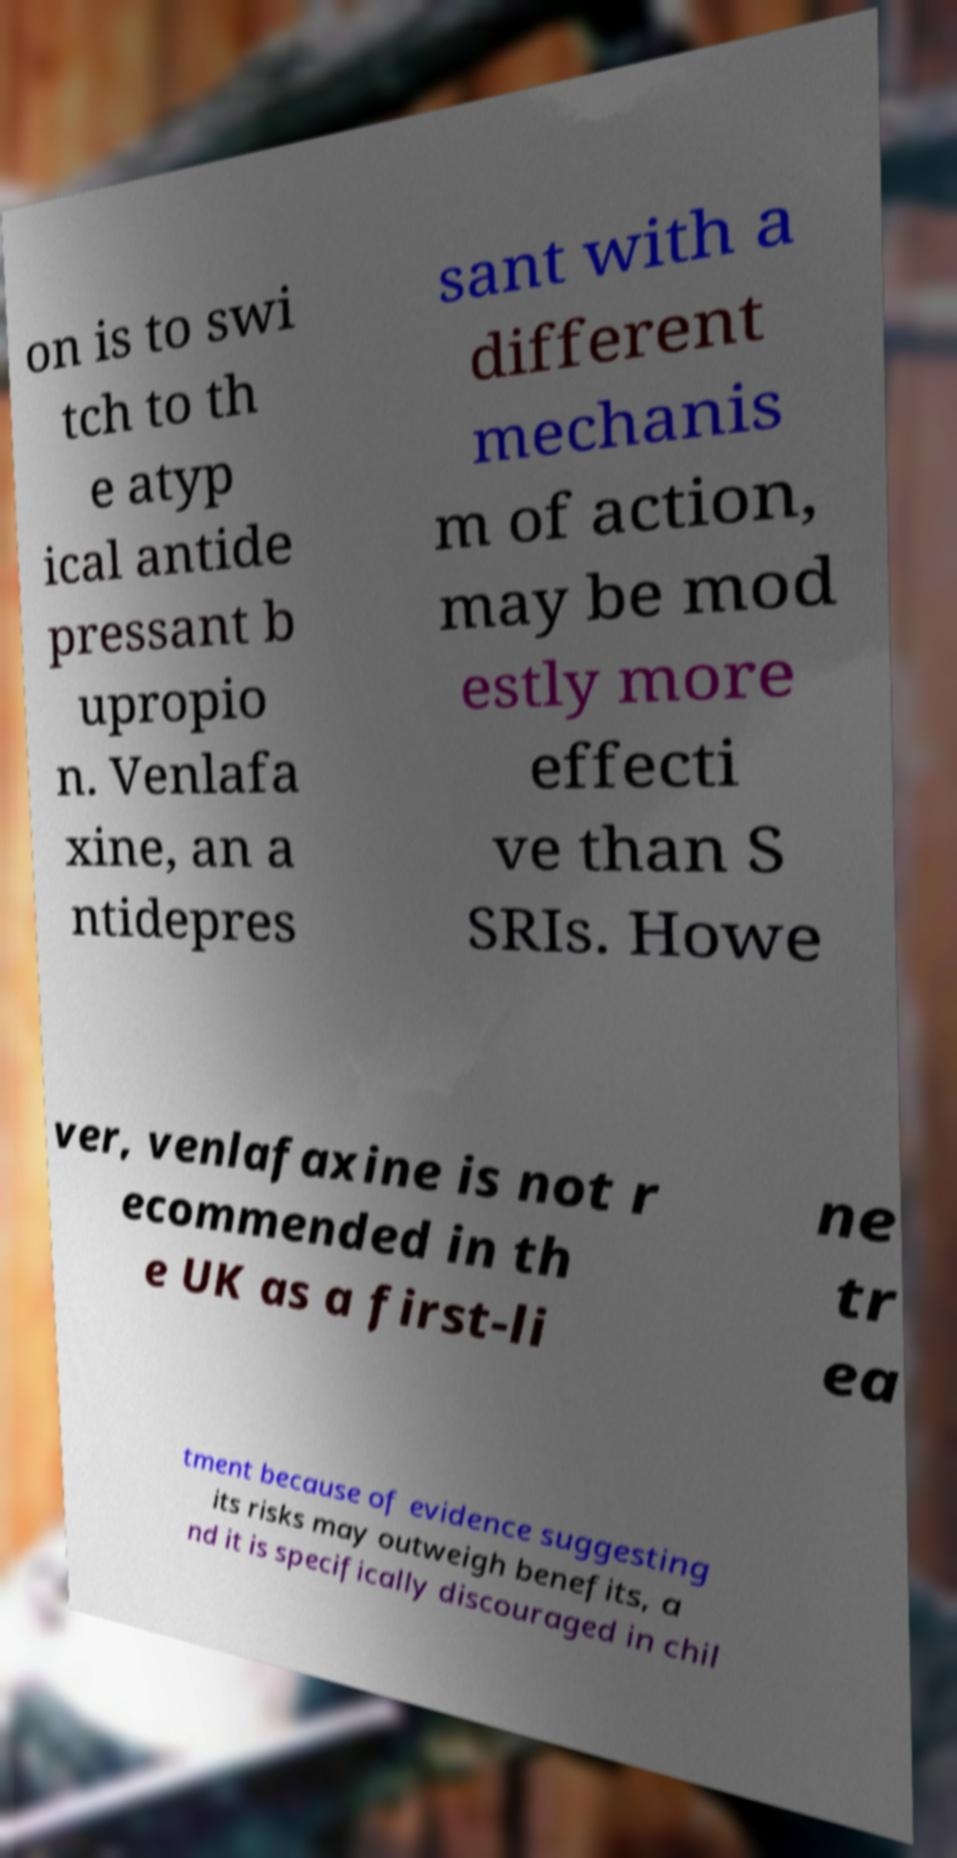Can you accurately transcribe the text from the provided image for me? on is to swi tch to th e atyp ical antide pressant b upropio n. Venlafa xine, an a ntidepres sant with a different mechanis m of action, may be mod estly more effecti ve than S SRIs. Howe ver, venlafaxine is not r ecommended in th e UK as a first-li ne tr ea tment because of evidence suggesting its risks may outweigh benefits, a nd it is specifically discouraged in chil 